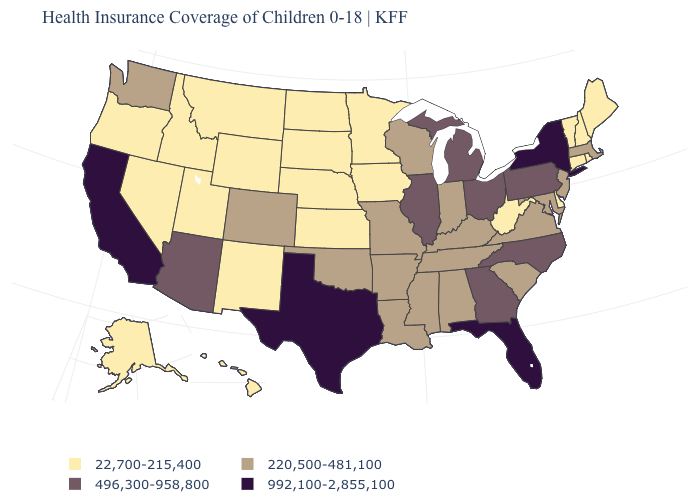Among the states that border Arizona , which have the highest value?
Write a very short answer. California. How many symbols are there in the legend?
Keep it brief. 4. Name the states that have a value in the range 22,700-215,400?
Answer briefly. Alaska, Connecticut, Delaware, Hawaii, Idaho, Iowa, Kansas, Maine, Minnesota, Montana, Nebraska, Nevada, New Hampshire, New Mexico, North Dakota, Oregon, Rhode Island, South Dakota, Utah, Vermont, West Virginia, Wyoming. Which states have the lowest value in the South?
Be succinct. Delaware, West Virginia. Does the map have missing data?
Write a very short answer. No. What is the value of Tennessee?
Write a very short answer. 220,500-481,100. What is the value of Connecticut?
Short answer required. 22,700-215,400. Among the states that border Arizona , which have the lowest value?
Quick response, please. Nevada, New Mexico, Utah. What is the highest value in states that border Texas?
Keep it brief. 220,500-481,100. What is the value of Kentucky?
Give a very brief answer. 220,500-481,100. What is the value of California?
Be succinct. 992,100-2,855,100. Name the states that have a value in the range 22,700-215,400?
Concise answer only. Alaska, Connecticut, Delaware, Hawaii, Idaho, Iowa, Kansas, Maine, Minnesota, Montana, Nebraska, Nevada, New Hampshire, New Mexico, North Dakota, Oregon, Rhode Island, South Dakota, Utah, Vermont, West Virginia, Wyoming. What is the value of New Mexico?
Keep it brief. 22,700-215,400. Does Pennsylvania have a lower value than New Mexico?
Write a very short answer. No. 